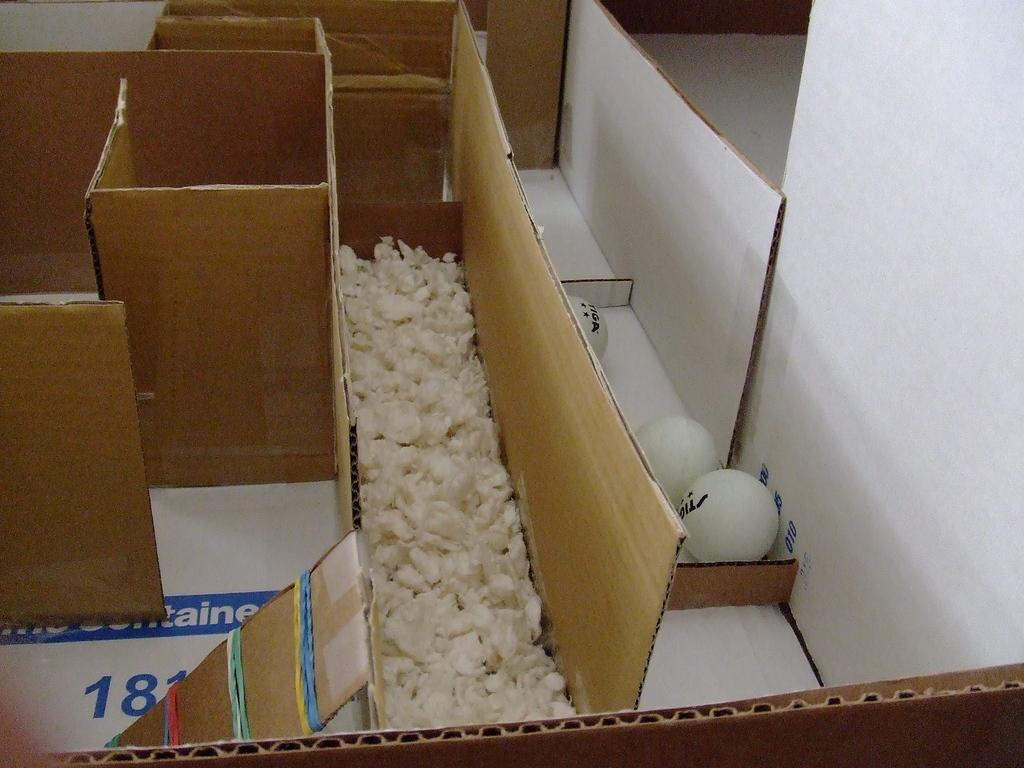<image>
Offer a succinct explanation of the picture presented. A dungeon made out of cardboard with the number 18 on it and with eggs in the final part of the dungeon. 